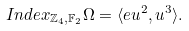Convert formula to latex. <formula><loc_0><loc_0><loc_500><loc_500>I n d e x _ { \mathbb { Z } _ { 4 } , \mathbb { F } _ { 2 } } \Omega = \langle e u ^ { 2 } , u ^ { 3 } \rangle .</formula> 